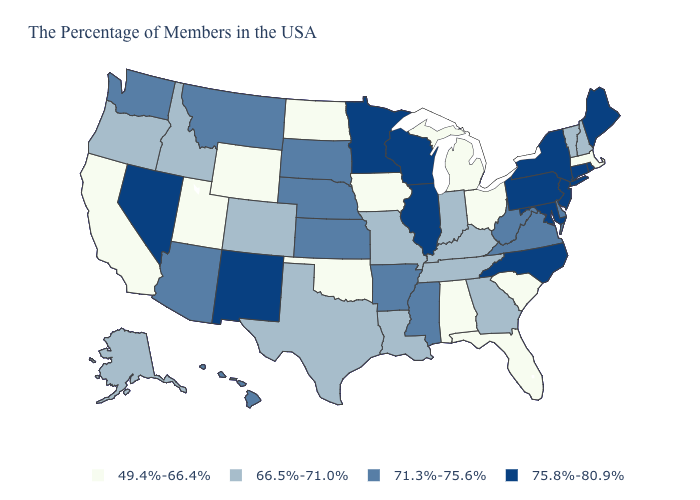Does Louisiana have the lowest value in the South?
Write a very short answer. No. Which states have the lowest value in the USA?
Quick response, please. Massachusetts, South Carolina, Ohio, Florida, Michigan, Alabama, Iowa, Oklahoma, North Dakota, Wyoming, Utah, California. Does the map have missing data?
Concise answer only. No. Name the states that have a value in the range 75.8%-80.9%?
Keep it brief. Maine, Rhode Island, Connecticut, New York, New Jersey, Maryland, Pennsylvania, North Carolina, Wisconsin, Illinois, Minnesota, New Mexico, Nevada. Name the states that have a value in the range 66.5%-71.0%?
Short answer required. New Hampshire, Vermont, Georgia, Kentucky, Indiana, Tennessee, Louisiana, Missouri, Texas, Colorado, Idaho, Oregon, Alaska. What is the value of Colorado?
Keep it brief. 66.5%-71.0%. What is the value of Wisconsin?
Answer briefly. 75.8%-80.9%. Which states have the highest value in the USA?
Quick response, please. Maine, Rhode Island, Connecticut, New York, New Jersey, Maryland, Pennsylvania, North Carolina, Wisconsin, Illinois, Minnesota, New Mexico, Nevada. What is the value of Connecticut?
Concise answer only. 75.8%-80.9%. Does Kansas have the same value as Maryland?
Answer briefly. No. What is the highest value in the USA?
Write a very short answer. 75.8%-80.9%. Does South Dakota have a higher value than Georgia?
Quick response, please. Yes. What is the value of Colorado?
Write a very short answer. 66.5%-71.0%. Is the legend a continuous bar?
Quick response, please. No. Which states have the highest value in the USA?
Write a very short answer. Maine, Rhode Island, Connecticut, New York, New Jersey, Maryland, Pennsylvania, North Carolina, Wisconsin, Illinois, Minnesota, New Mexico, Nevada. 